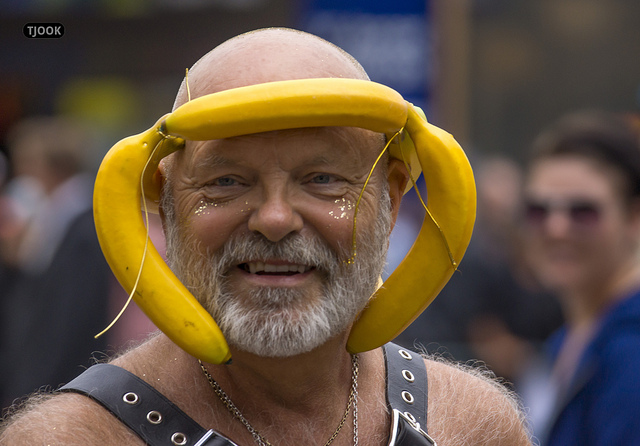Identify the text contained in this image. TJOOK 